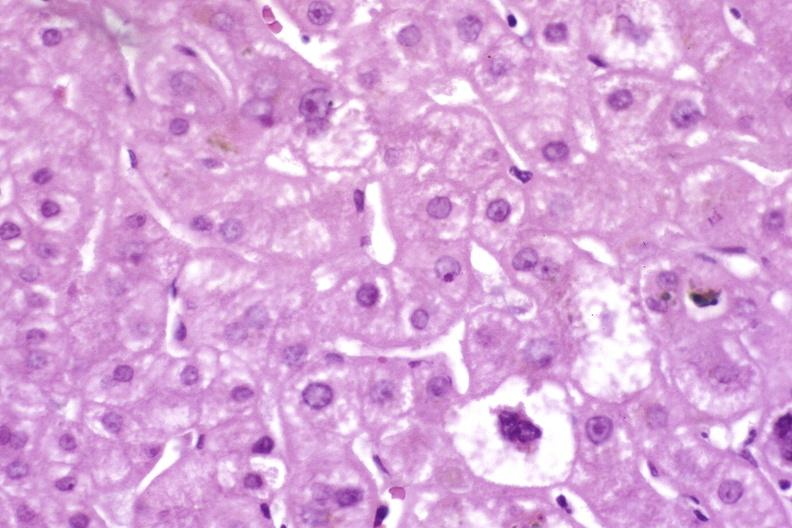s coronary artery present?
Answer the question using a single word or phrase. No 